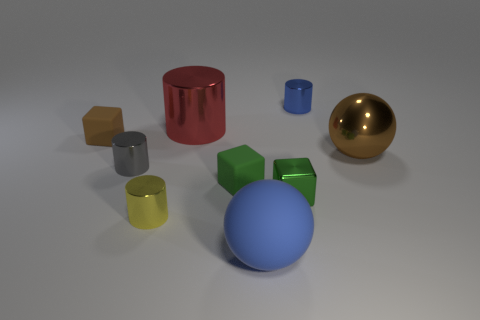Do the big metallic ball and the rubber block to the left of the small yellow metallic thing have the same color?
Your response must be concise. Yes. Is there a small metal cylinder of the same color as the matte sphere?
Your response must be concise. Yes. What shape is the tiny matte object that is the same color as the metal ball?
Provide a succinct answer. Cube. There is a green object that is made of the same material as the tiny blue object; what shape is it?
Offer a very short reply. Cube. Are there any other things of the same color as the large matte thing?
Your answer should be compact. Yes. What material is the small gray object that is the same shape as the large red metallic thing?
Provide a short and direct response. Metal. What number of other objects are the same size as the blue matte ball?
Give a very brief answer. 2. There is a tiny green object left of the large rubber sphere; is it the same shape as the big red metallic thing?
Provide a short and direct response. No. What number of other objects are there of the same shape as the small green metallic thing?
Your response must be concise. 2. There is a brown object on the right side of the rubber ball; what is its shape?
Provide a succinct answer. Sphere. 